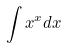Convert formula to latex. <formula><loc_0><loc_0><loc_500><loc_500>\int x ^ { x } d x</formula> 